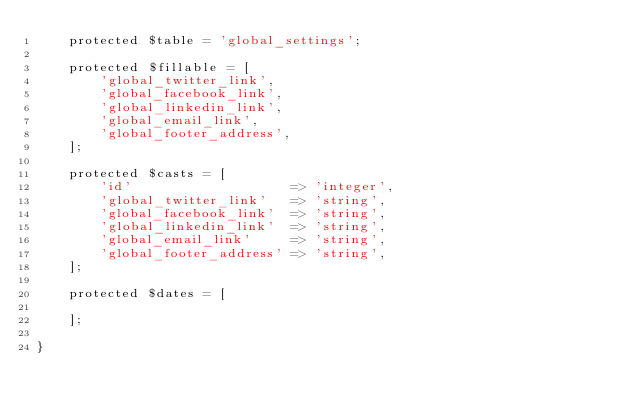<code> <loc_0><loc_0><loc_500><loc_500><_PHP_>    protected $table = 'global_settings';

    protected $fillable = [
        'global_twitter_link',
        'global_facebook_link',
        'global_linkedin_link',
        'global_email_link',
        'global_footer_address',
    ];

    protected $casts = [
        'id'                    => 'integer',
        'global_twitter_link'   => 'string',
        'global_facebook_link'  => 'string',
        'global_linkedin_link'  => 'string',
        'global_email_link'     => 'string',
        'global_footer_address' => 'string',
    ];

    protected $dates = [

    ];

}
</code> 